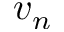<formula> <loc_0><loc_0><loc_500><loc_500>v _ { n }</formula> 